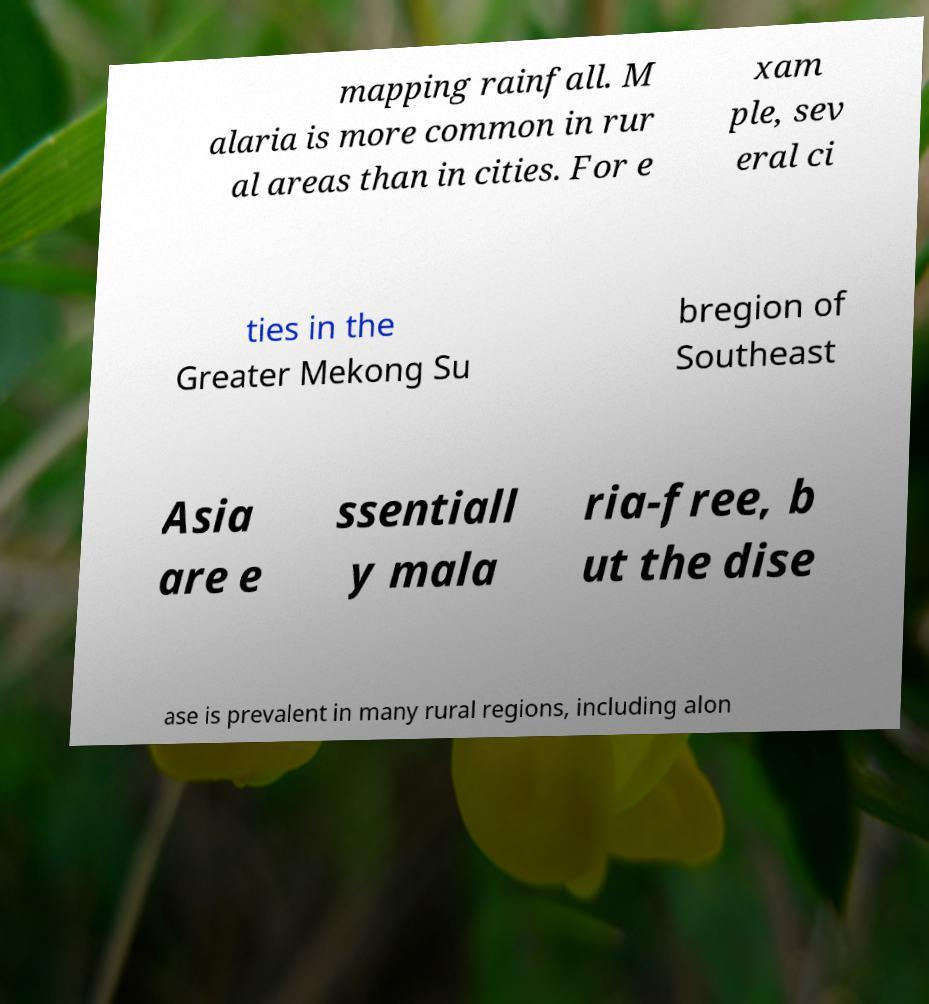Could you extract and type out the text from this image? mapping rainfall. M alaria is more common in rur al areas than in cities. For e xam ple, sev eral ci ties in the Greater Mekong Su bregion of Southeast Asia are e ssentiall y mala ria-free, b ut the dise ase is prevalent in many rural regions, including alon 